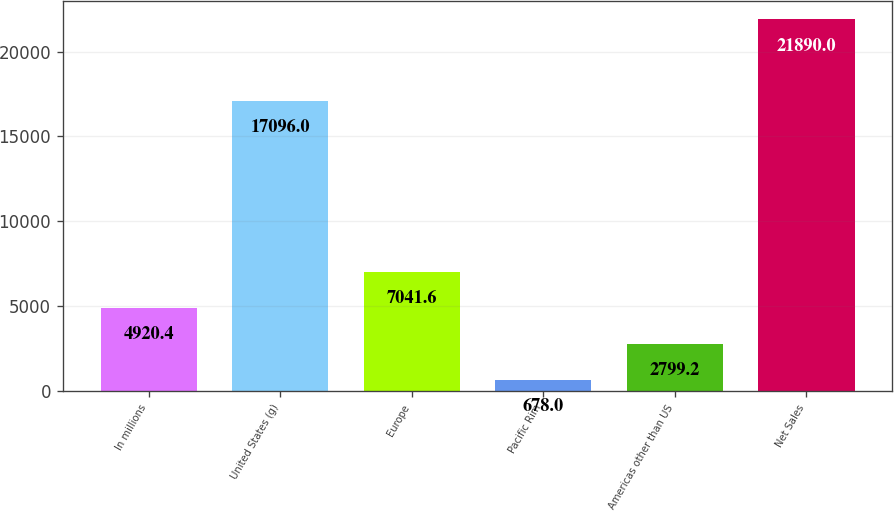Convert chart to OTSL. <chart><loc_0><loc_0><loc_500><loc_500><bar_chart><fcel>In millions<fcel>United States (g)<fcel>Europe<fcel>Pacific Rim<fcel>Americas other than US<fcel>Net Sales<nl><fcel>4920.4<fcel>17096<fcel>7041.6<fcel>678<fcel>2799.2<fcel>21890<nl></chart> 